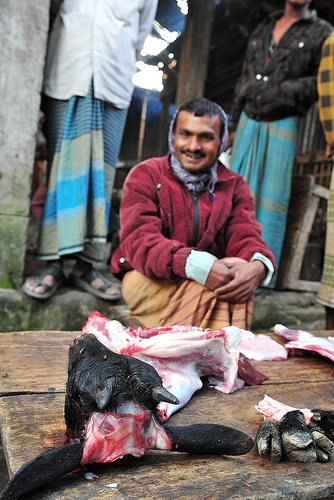<image>
Can you confirm if the board is above the man? No. The board is not positioned above the man. The vertical arrangement shows a different relationship. 